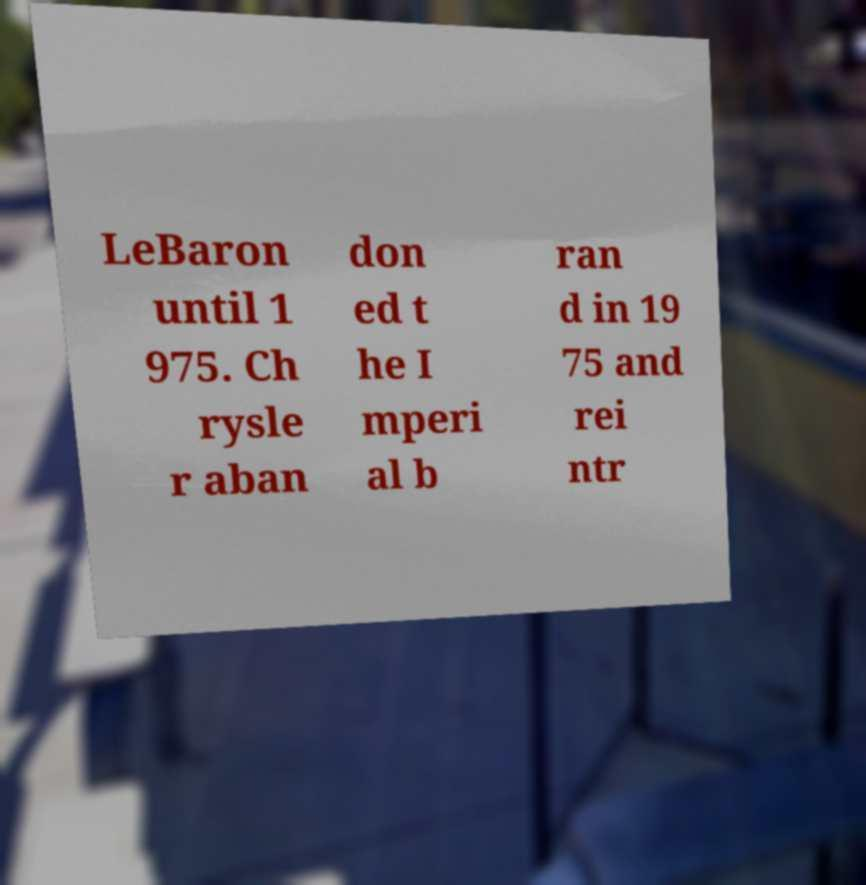I need the written content from this picture converted into text. Can you do that? LeBaron until 1 975. Ch rysle r aban don ed t he I mperi al b ran d in 19 75 and rei ntr 